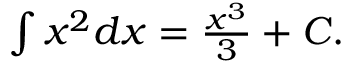<formula> <loc_0><loc_0><loc_500><loc_500>\int x ^ { 2 } d x = { \frac { x ^ { 3 } } { 3 } } + C .</formula> 